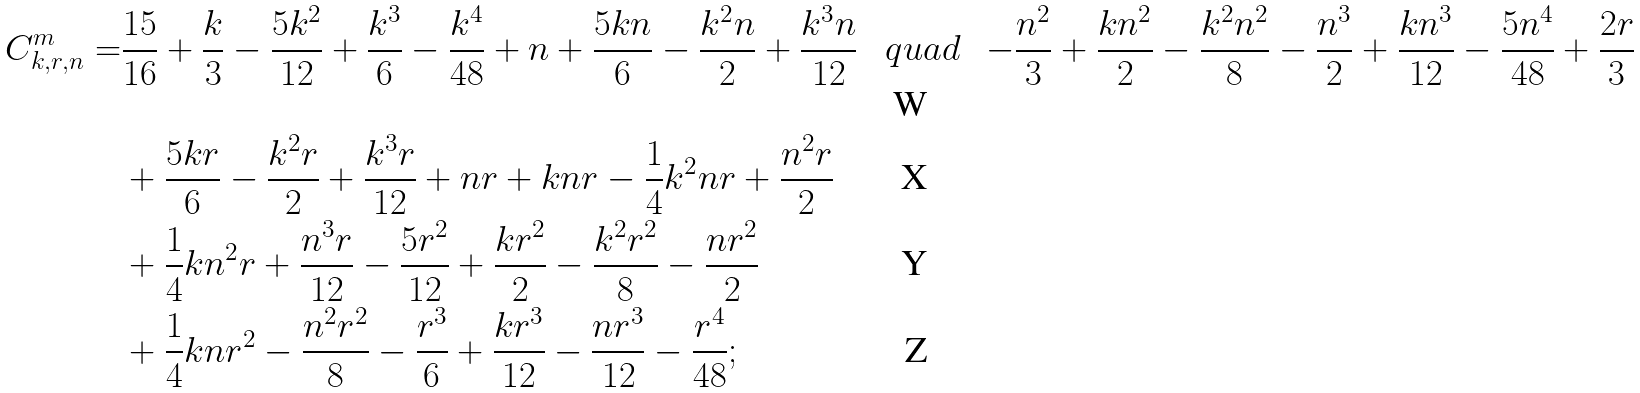<formula> <loc_0><loc_0><loc_500><loc_500>C ^ { m } _ { k , r , n } = & \frac { 1 5 } { 1 6 } + \frac { k } { 3 } - \frac { 5 k ^ { 2 } } { 1 2 } + \frac { k ^ { 3 } } { 6 } - \frac { k ^ { 4 } } { 4 8 } + n + \frac { 5 k n } { 6 } - \frac { k ^ { 2 } n } { 2 } + \frac { k ^ { 3 } n } { 1 2 } \ \ \ q u a d \ & - \frac { n ^ { 2 } } { 3 } + \frac { k n ^ { 2 } } { 2 } - \frac { k ^ { 2 } n ^ { 2 } } { 8 } - \frac { n ^ { 3 } } { 2 } + \frac { k n ^ { 3 } } { 1 2 } - \frac { 5 n ^ { 4 } } { 4 8 } + \frac { 2 r } { 3 } \\ & + \frac { 5 k r } { 6 } - \frac { k ^ { 2 } r } { 2 } + \frac { k ^ { 3 } r } { 1 2 } + n r + k n r - \frac { 1 } { 4 } k ^ { 2 } n r + \frac { n ^ { 2 } r } { 2 } \\ & + \frac { 1 } { 4 } k n ^ { 2 } r + \frac { n ^ { 3 } r } { 1 2 } - \frac { 5 r ^ { 2 } } { 1 2 } + \frac { k r ^ { 2 } } { 2 } - \frac { k ^ { 2 } r ^ { 2 } } { 8 } - \frac { n r ^ { 2 } } { 2 } \\ & + \frac { 1 } { 4 } k n r ^ { 2 } - \frac { n ^ { 2 } r ^ { 2 } } { 8 } - \frac { r ^ { 3 } } { 6 } + \frac { k r ^ { 3 } } { 1 2 } - \frac { n r ^ { 3 } } { 1 2 } - \frac { r ^ { 4 } } { 4 8 } ;</formula> 